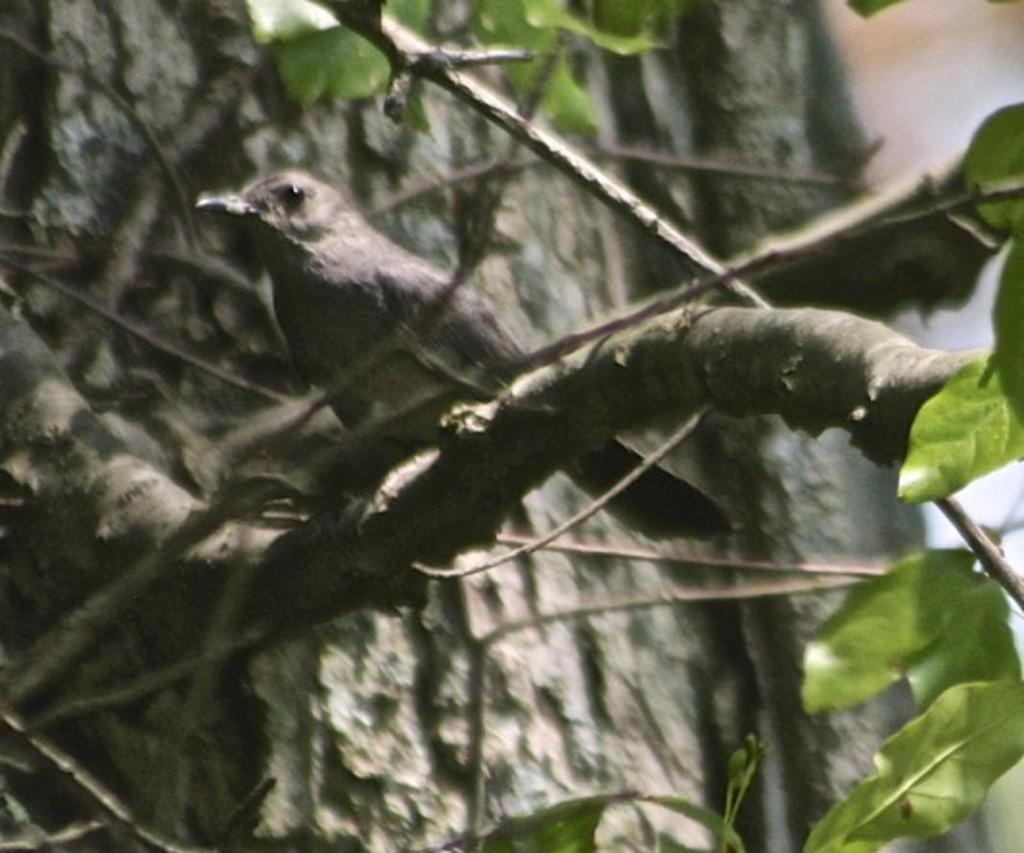What type of animal can be seen in the image? There is a bird in the image. Where is the bird located? The bird is standing on a branch of a tree. What else can be seen in the image besides the bird? There are leaves visible in the image. What is the bird's reaction to the disgusting drain in the image? There is no drain present in the image, and therefore no reaction from the bird can be observed. 